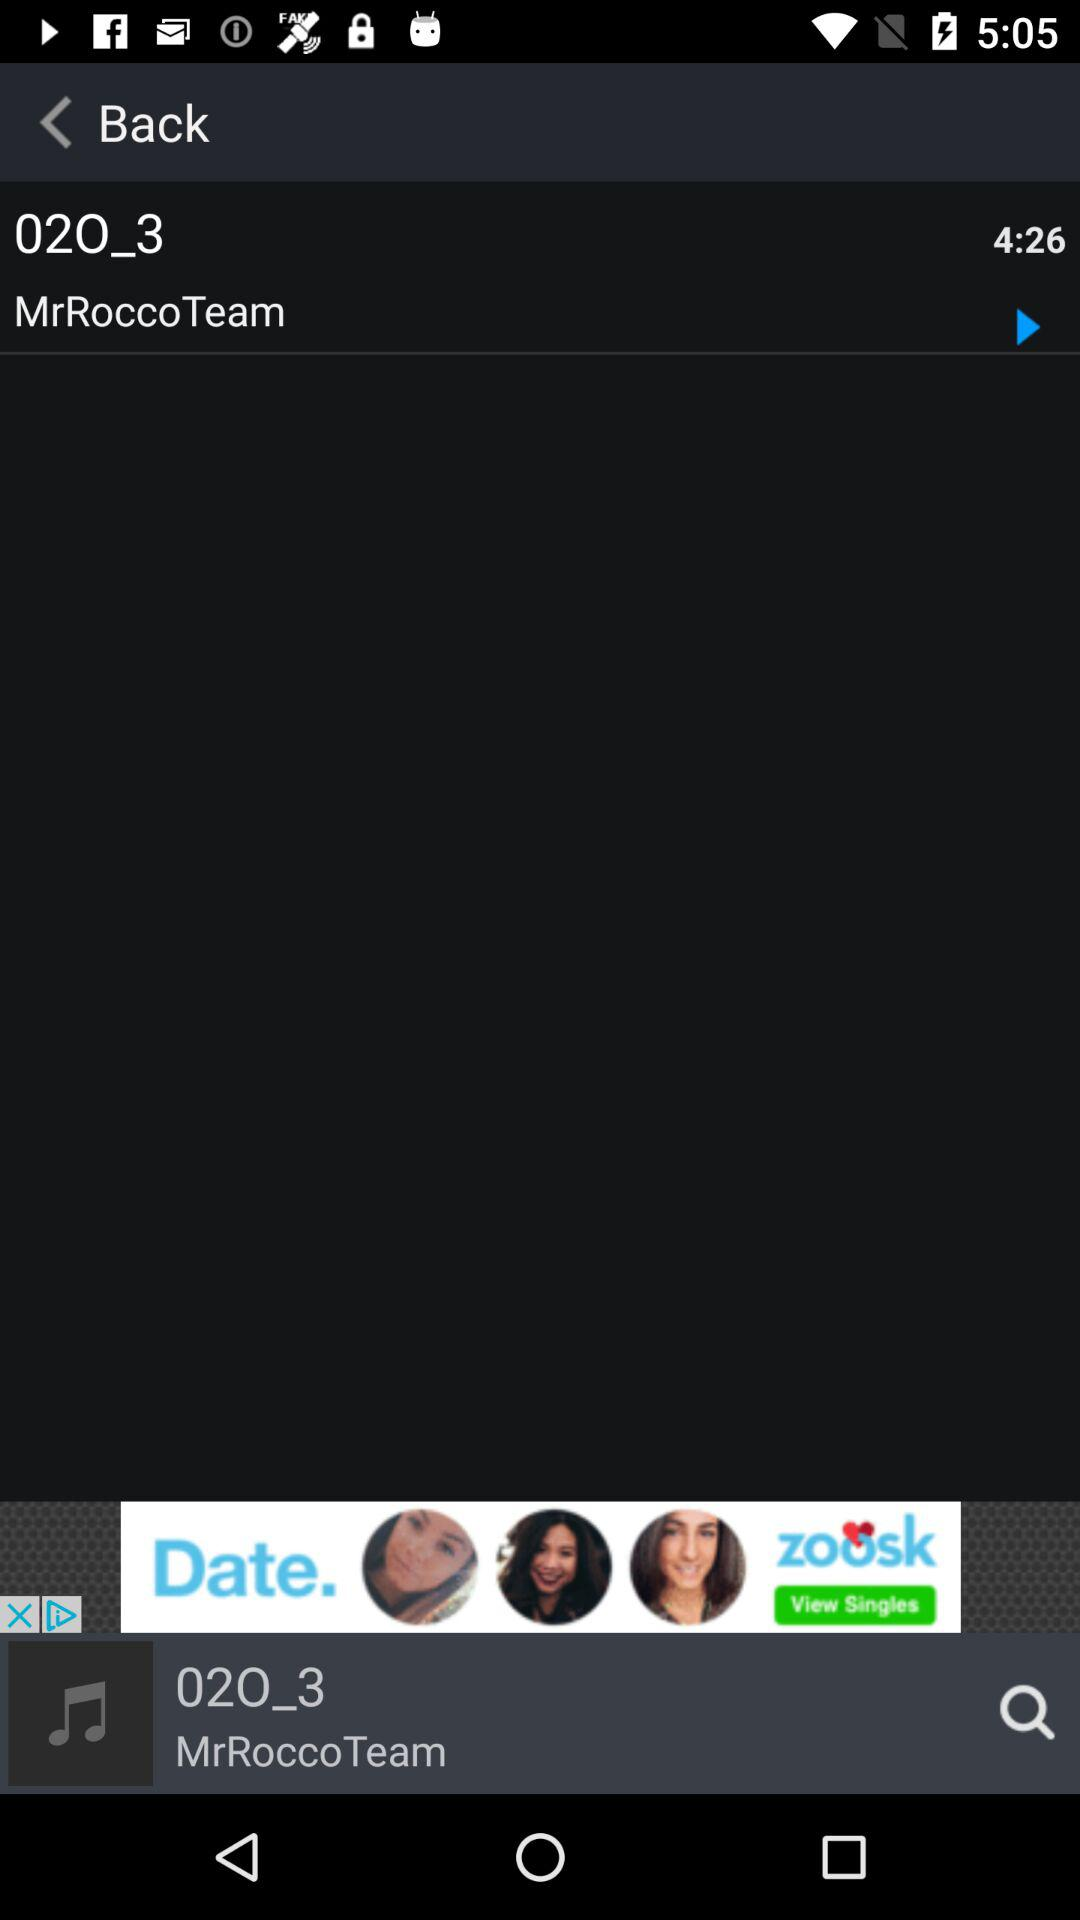Which song is playing now? The song is "MrRoccoTeam". 